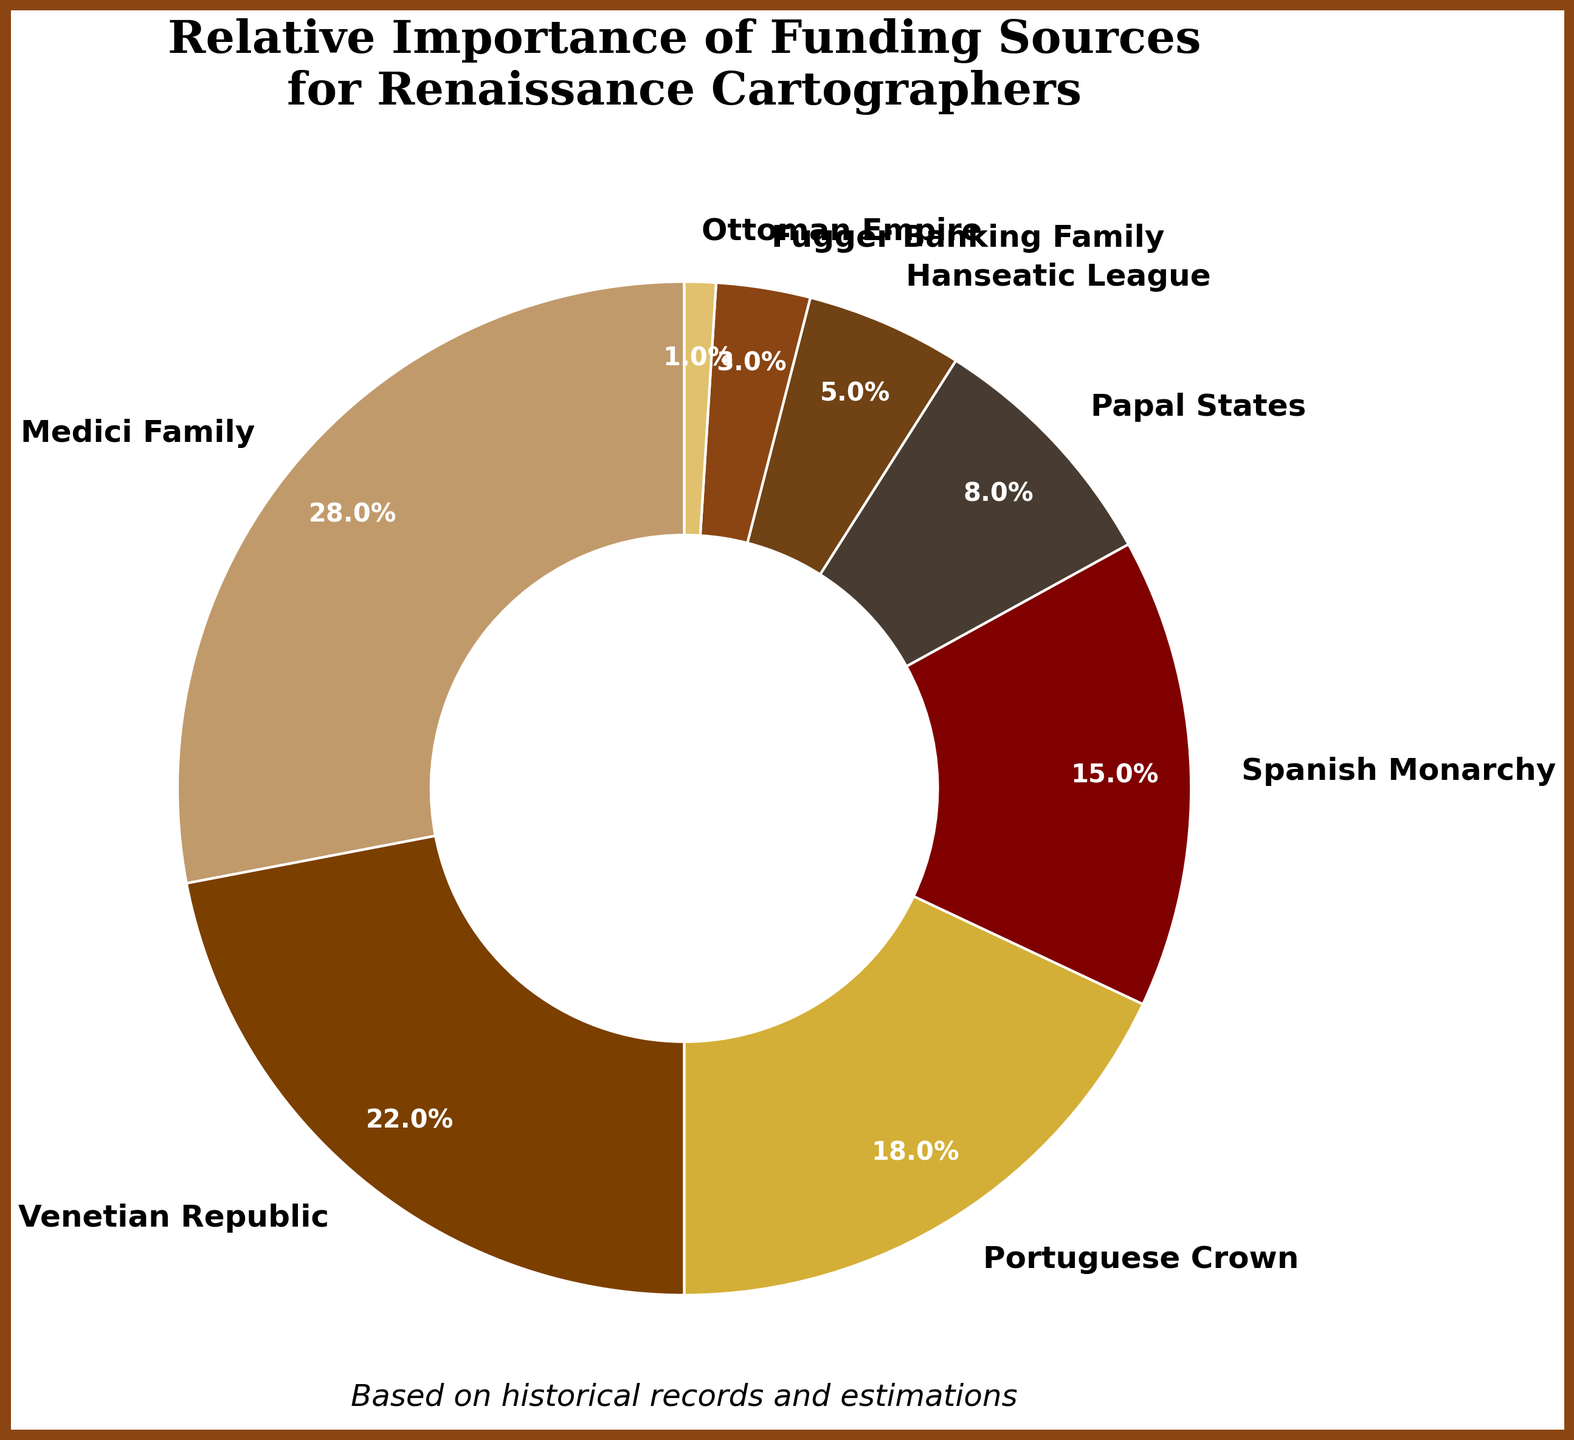What is the largest funding source for Renaissance cartographers? Look at the figure to identify which slice of the pie chart occupies the largest area. The label with the largest percentage will be the largest funding source.
Answer: Medici Family Which funding source contributed the least? Identify the smallest slice of the pie chart. The label with the smallest percentage represents the lowest contribution.
Answer: Ottoman Empire How much more did the Medici Family contribute compared to the Hanseatic League? Find the percentages for both the Medici Family and the Hanseatic League. Subtract the Hanseatic League's percentage from the Medici Family's percentage (28% - 5% = 23%).
Answer: 23% What is the combined contribution of the Portuguese Crown and the Spanish Monarchy? Add the percentages of the Portuguese Crown (18%) and the Spanish Monarchy (15%): 18% + 15% = 33%.
Answer: 33% Which funding sources contributed more than 20% each? Identify the slices of the pie chart with percentages greater than 20%. These slices will be labeled with their respective funding sources.
Answer: Medici Family, Venetian Republic Is the contribution of the Papal States greater than that of the Fugger Banking Family? Compare the percentages of the Papal States (8%) and the Fugger Banking Family (3%). Since 8% is more than 3%, the Papal States' contribution is greater.
Answer: Yes What is the total contribution of all funding sources below 10%? Add the percentages of all funding sources contributing less than 10%: Papal States (8%), Hanseatic League (5%), Fugger Banking Family (3%), Ottoman Empire (1%). 8% + 5% + 3% + 1% = 17%.
Answer: 17% Which funding source, excluding the Medici Family, contributed the second highest amount? Apart from the Medici Family, identify the second largest slice of the pie chart and check the label.
Answer: Venetian Republic If the contributions of the Venetian Republic and the Portuguese Crown were combined, would their combined contribution exceed that of the Medici Family? Add the percentages of the Venetian Republic (22%) and the Portuguese Crown (18%). Compare the result to the Medici Family's contribution (28%). 22% + 18% = 40%, which is greater than 28%.
Answer: Yes 